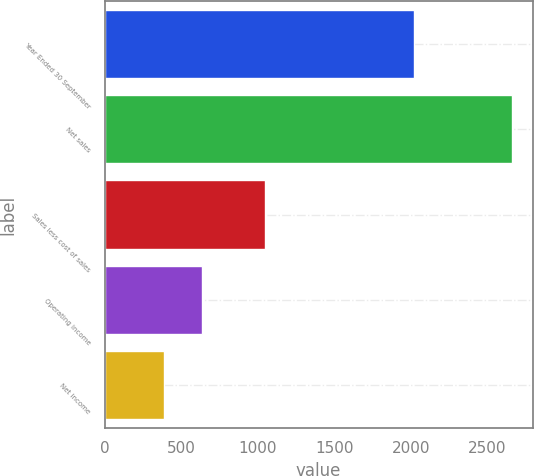Convert chart. <chart><loc_0><loc_0><loc_500><loc_500><bar_chart><fcel>Year Ended 30 September<fcel>Net sales<fcel>Sales less cost of sales<fcel>Operating income<fcel>Net income<nl><fcel>2018<fcel>2663.1<fcel>1050.6<fcel>635.3<fcel>388<nl></chart> 